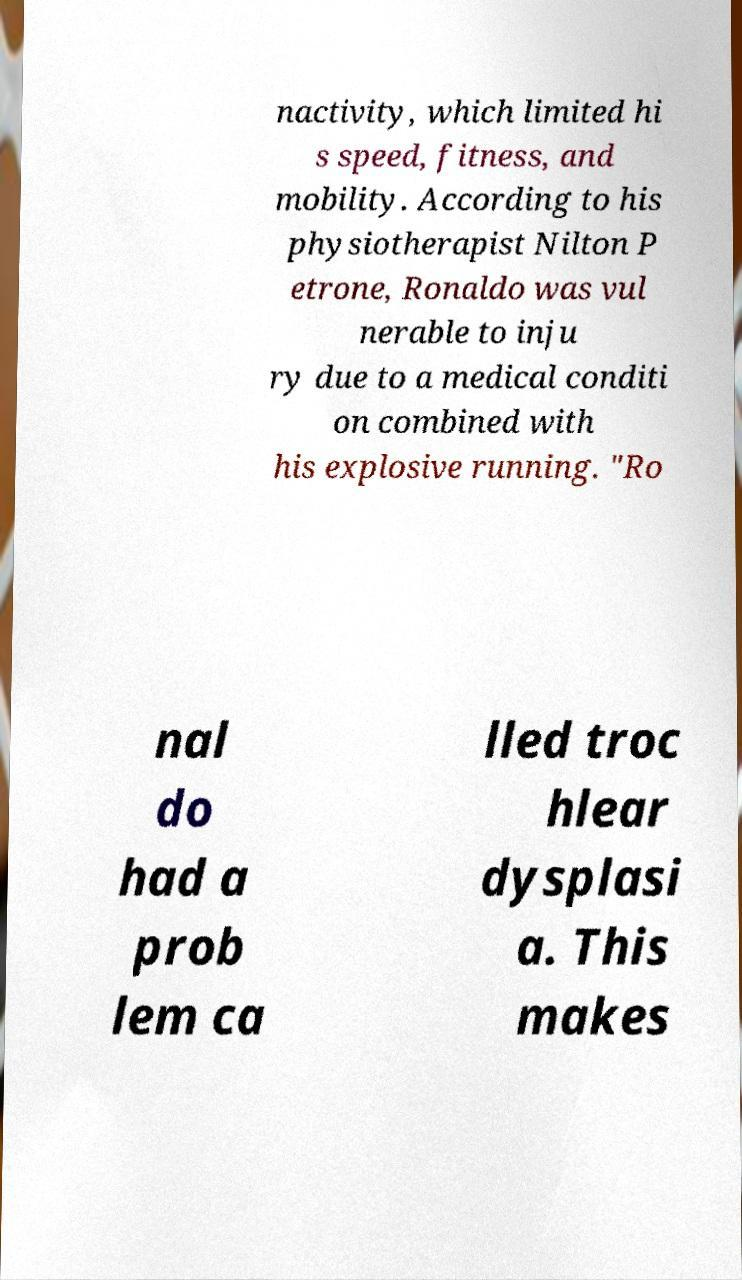Could you extract and type out the text from this image? nactivity, which limited hi s speed, fitness, and mobility. According to his physiotherapist Nilton P etrone, Ronaldo was vul nerable to inju ry due to a medical conditi on combined with his explosive running. "Ro nal do had a prob lem ca lled troc hlear dysplasi a. This makes 